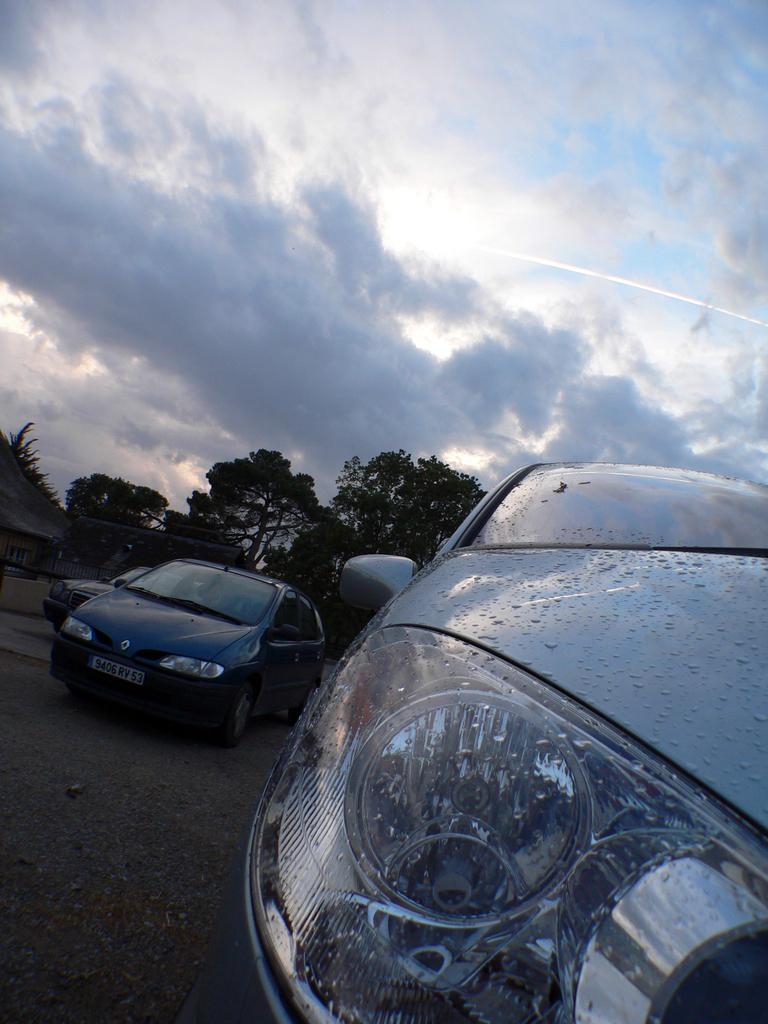In one or two sentences, can you explain what this image depicts? This picture is clicked outside. In the foreground we can see the cars and trees. On the left corner there is a house. In the background there is a sky. 